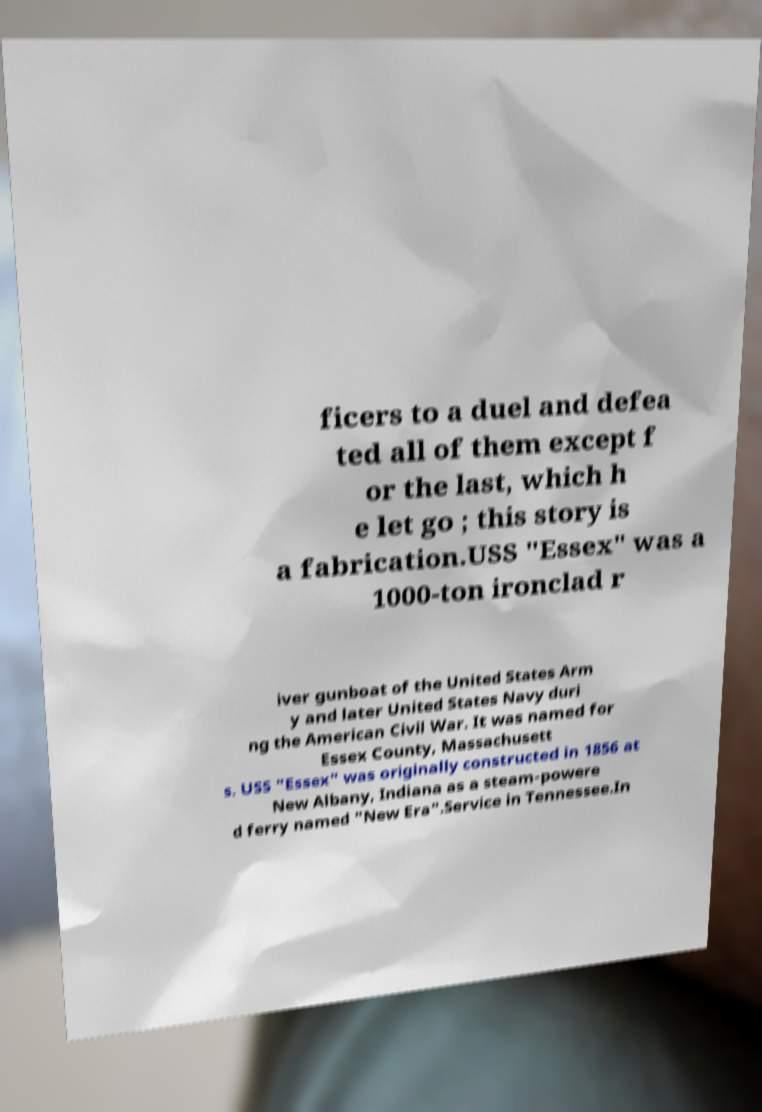Can you read and provide the text displayed in the image?This photo seems to have some interesting text. Can you extract and type it out for me? ficers to a duel and defea ted all of them except f or the last, which h e let go ; this story is a fabrication.USS "Essex" was a 1000-ton ironclad r iver gunboat of the United States Arm y and later United States Navy duri ng the American Civil War. It was named for Essex County, Massachusett s. USS "Essex" was originally constructed in 1856 at New Albany, Indiana as a steam-powere d ferry named "New Era".Service in Tennessee.In 